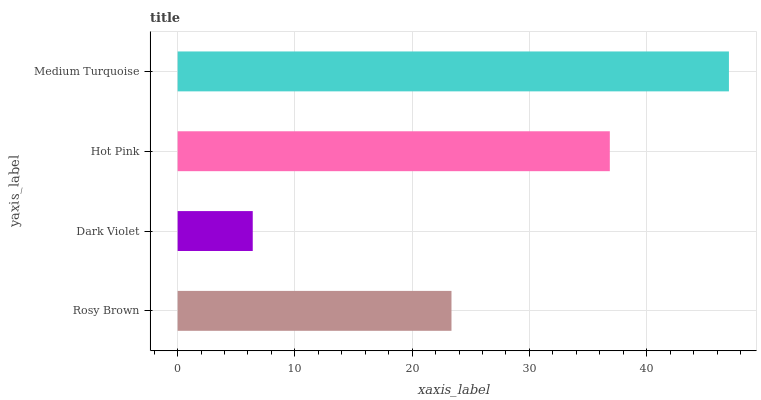Is Dark Violet the minimum?
Answer yes or no. Yes. Is Medium Turquoise the maximum?
Answer yes or no. Yes. Is Hot Pink the minimum?
Answer yes or no. No. Is Hot Pink the maximum?
Answer yes or no. No. Is Hot Pink greater than Dark Violet?
Answer yes or no. Yes. Is Dark Violet less than Hot Pink?
Answer yes or no. Yes. Is Dark Violet greater than Hot Pink?
Answer yes or no. No. Is Hot Pink less than Dark Violet?
Answer yes or no. No. Is Hot Pink the high median?
Answer yes or no. Yes. Is Rosy Brown the low median?
Answer yes or no. Yes. Is Rosy Brown the high median?
Answer yes or no. No. Is Hot Pink the low median?
Answer yes or no. No. 